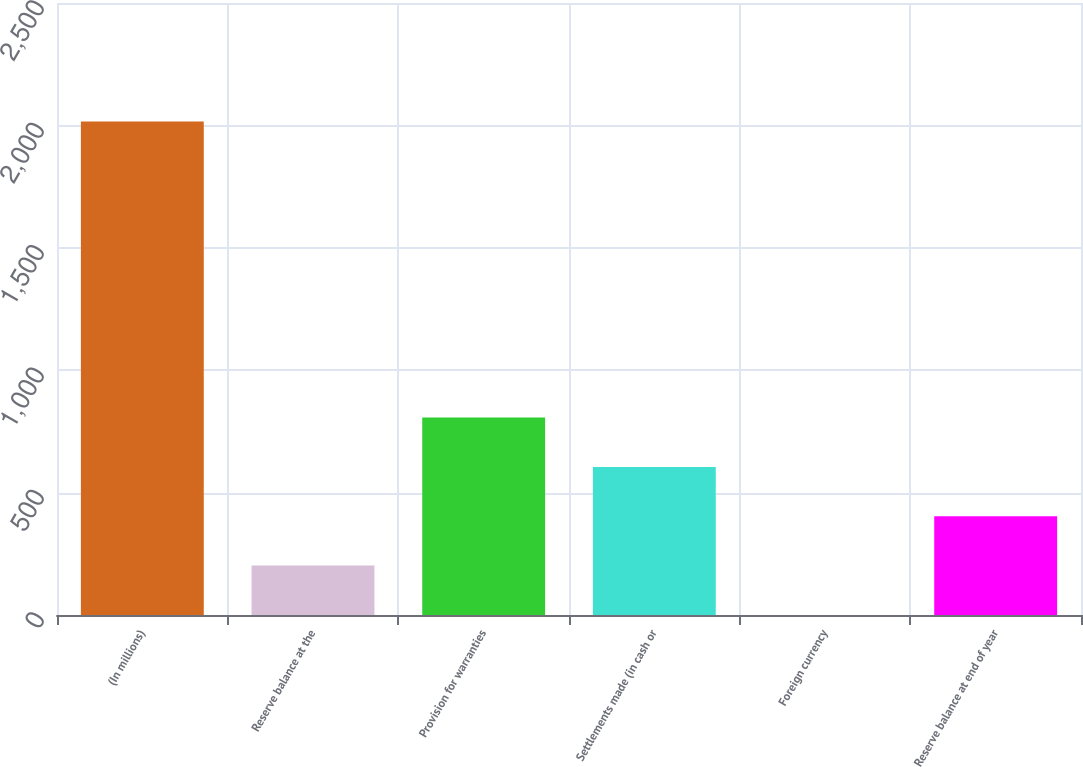Convert chart. <chart><loc_0><loc_0><loc_500><loc_500><bar_chart><fcel>(In millions)<fcel>Reserve balance at the<fcel>Provision for warranties<fcel>Settlements made (in cash or<fcel>Foreign currency<fcel>Reserve balance at end of year<nl><fcel>2016<fcel>201.96<fcel>806.64<fcel>605.08<fcel>0.4<fcel>403.52<nl></chart> 